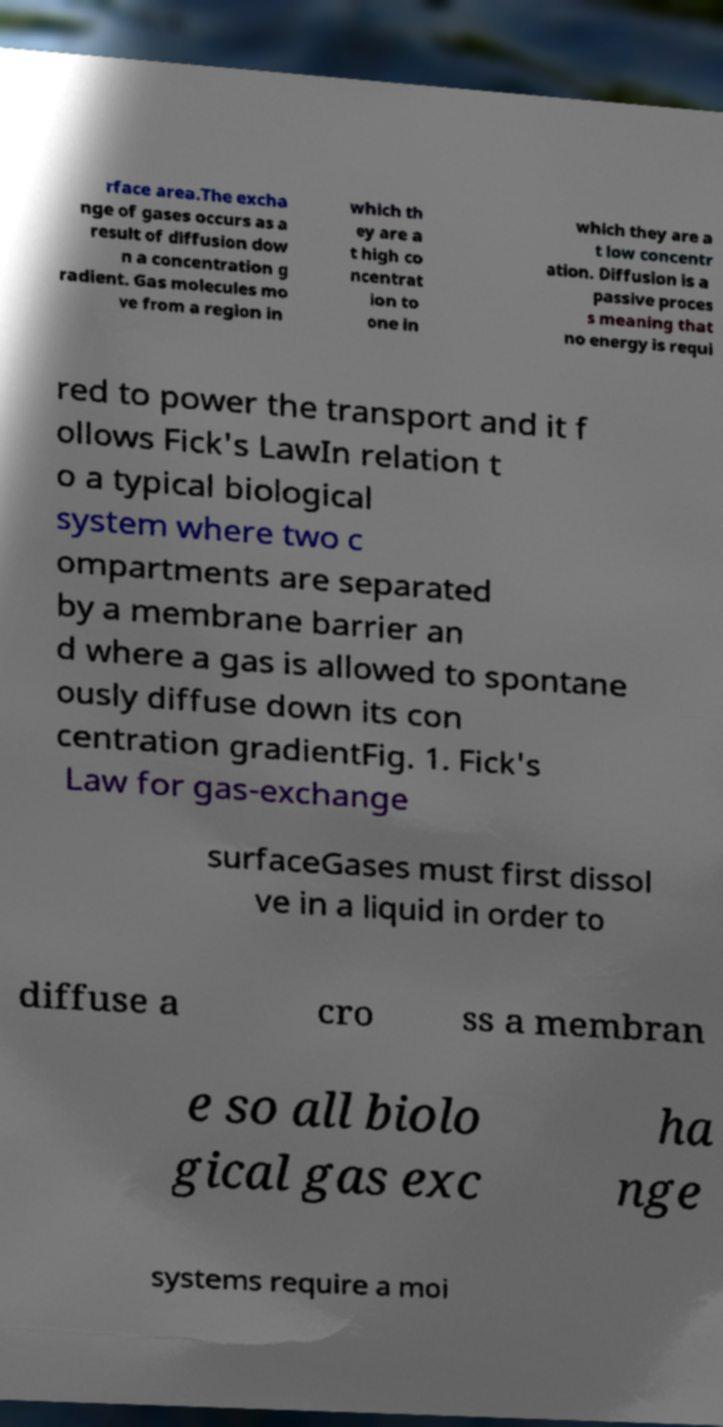For documentation purposes, I need the text within this image transcribed. Could you provide that? rface area.The excha nge of gases occurs as a result of diffusion dow n a concentration g radient. Gas molecules mo ve from a region in which th ey are a t high co ncentrat ion to one in which they are a t low concentr ation. Diffusion is a passive proces s meaning that no energy is requi red to power the transport and it f ollows Fick's LawIn relation t o a typical biological system where two c ompartments are separated by a membrane barrier an d where a gas is allowed to spontane ously diffuse down its con centration gradientFig. 1. Fick's Law for gas-exchange surfaceGases must first dissol ve in a liquid in order to diffuse a cro ss a membran e so all biolo gical gas exc ha nge systems require a moi 